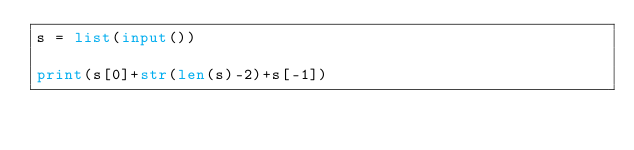<code> <loc_0><loc_0><loc_500><loc_500><_Python_>s = list(input())

print(s[0]+str(len(s)-2)+s[-1])

</code> 